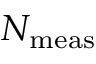<formula> <loc_0><loc_0><loc_500><loc_500>N _ { m e a s }</formula> 